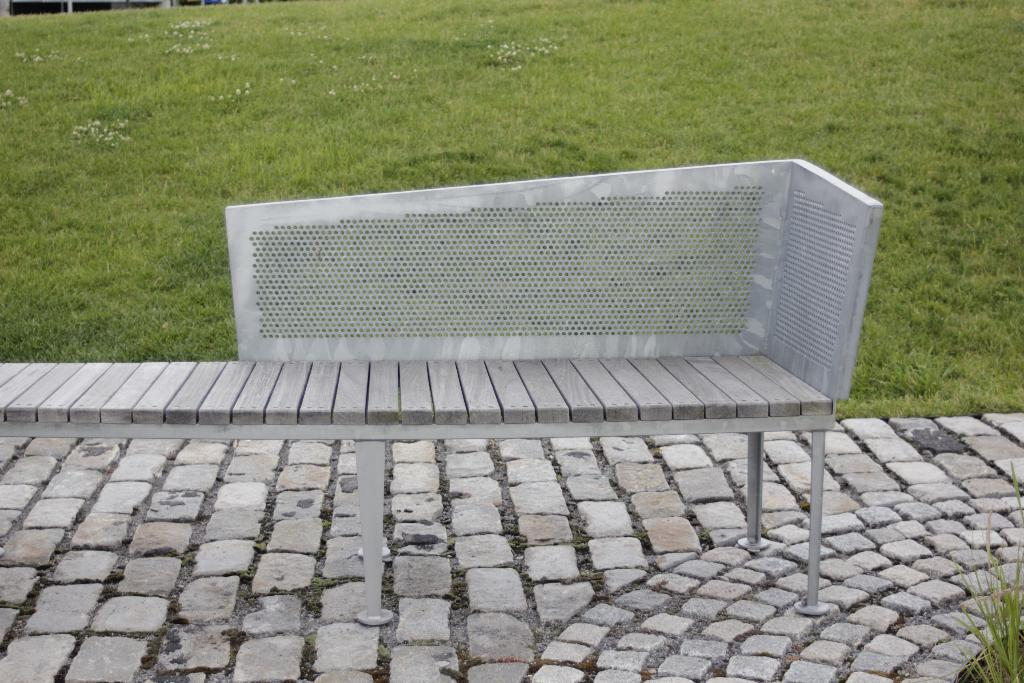What type of path is visible in the image? There is a stones path in the image. What is located on the stones path? There is a bench on the stones path. What can be seen behind the bench? There is a grass surface visible behind the bench. How many zebras are playing chess on the stones path in the image? There are no zebras or chess games present in the image. 